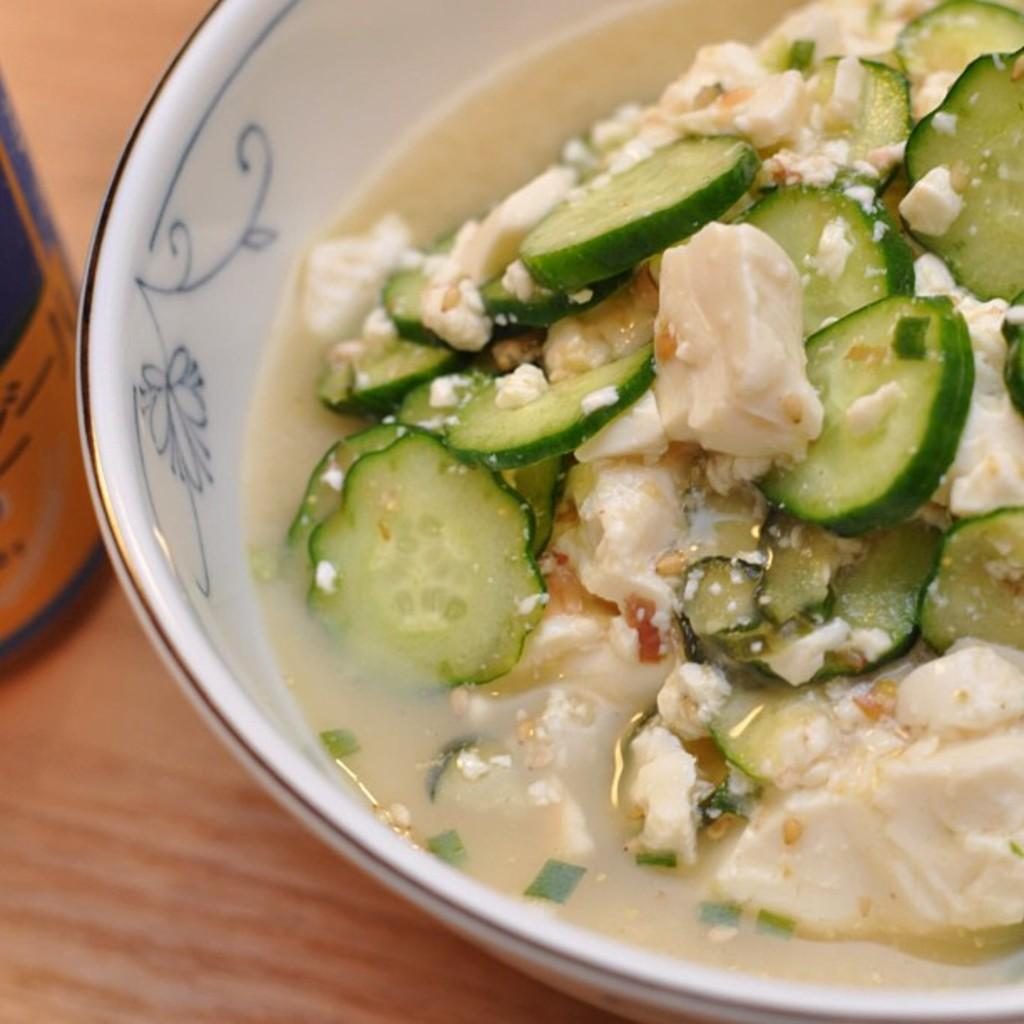What type of dishware is used for the food in the image? The food is in a white color bowl in the image. Where is the food located in the image? The food is on the right side of the image. What else can be seen on the left side of the image? There is an object on the left side of the image. What team is responsible for the trick in the image? There is no team or trick present in the image; it only features food in a white bowl and an object on the left side. 